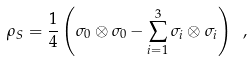Convert formula to latex. <formula><loc_0><loc_0><loc_500><loc_500>\rho _ { S } = \frac { 1 } { 4 } \left ( \sigma _ { 0 } \otimes \sigma _ { 0 } - \sum _ { i = 1 } ^ { 3 } \sigma _ { i } \otimes \sigma _ { i } \right ) \ ,</formula> 